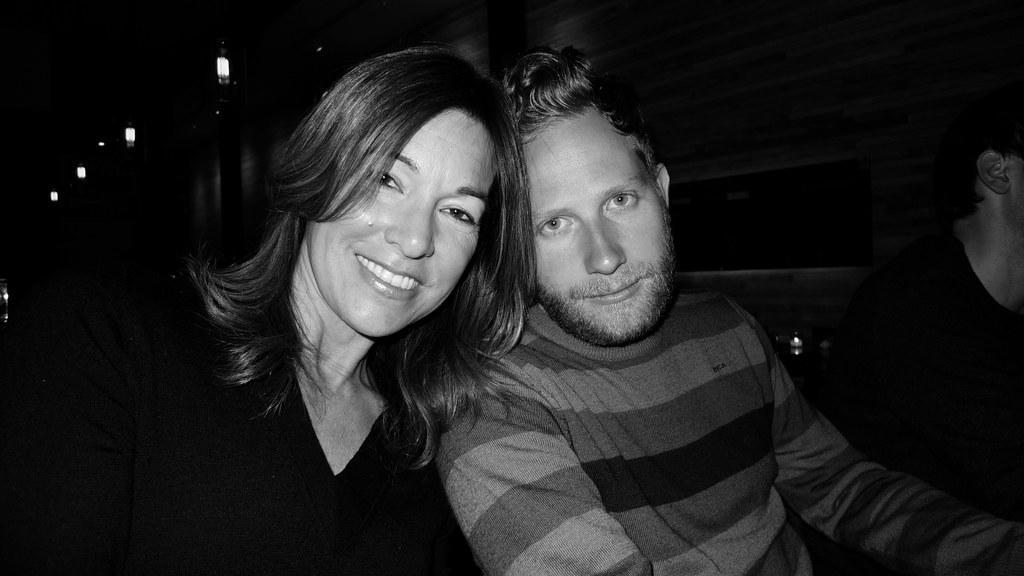Can you describe this image briefly? In this image, we can see a woman and man are watching and smiling. It is a black and white image. On the right side of the image, we can see a person. Background we can see wall, lights, few objects and dark view. 